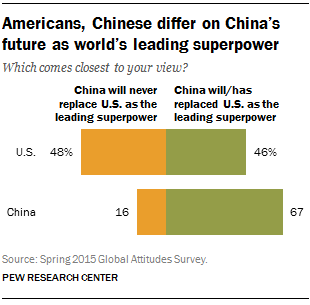Give some essential details in this illustration. In the US category, the ratio between two answers is 2.031944444... The United States and China are the two countries that are being discussed in this context. 